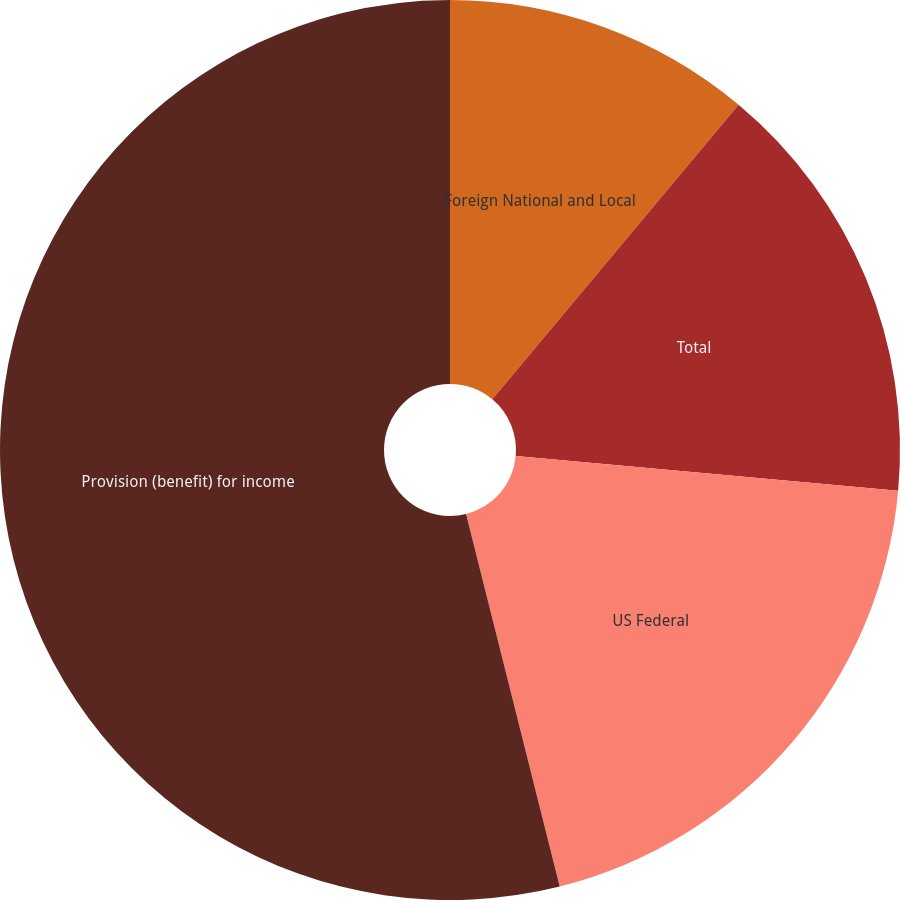<chart> <loc_0><loc_0><loc_500><loc_500><pie_chart><fcel>Foreign National and Local<fcel>Total<fcel>US Federal<fcel>Provision (benefit) for income<nl><fcel>11.08%<fcel>15.36%<fcel>19.64%<fcel>53.92%<nl></chart> 